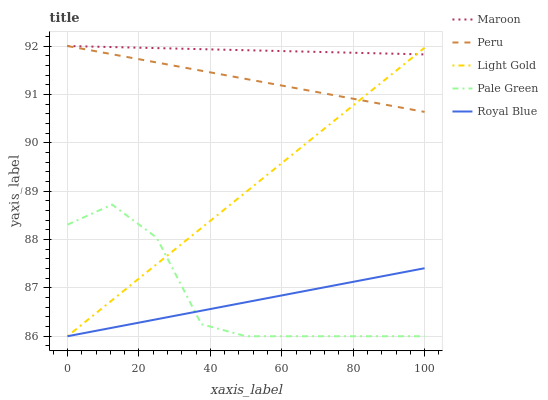Does Royal Blue have the minimum area under the curve?
Answer yes or no. Yes. Does Maroon have the maximum area under the curve?
Answer yes or no. Yes. Does Pale Green have the minimum area under the curve?
Answer yes or no. No. Does Pale Green have the maximum area under the curve?
Answer yes or no. No. Is Peru the smoothest?
Answer yes or no. Yes. Is Pale Green the roughest?
Answer yes or no. Yes. Is Light Gold the smoothest?
Answer yes or no. No. Is Light Gold the roughest?
Answer yes or no. No. Does Royal Blue have the lowest value?
Answer yes or no. Yes. Does Peru have the lowest value?
Answer yes or no. No. Does Maroon have the highest value?
Answer yes or no. Yes. Does Pale Green have the highest value?
Answer yes or no. No. Is Royal Blue less than Peru?
Answer yes or no. Yes. Is Maroon greater than Royal Blue?
Answer yes or no. Yes. Does Maroon intersect Peru?
Answer yes or no. Yes. Is Maroon less than Peru?
Answer yes or no. No. Is Maroon greater than Peru?
Answer yes or no. No. Does Royal Blue intersect Peru?
Answer yes or no. No. 